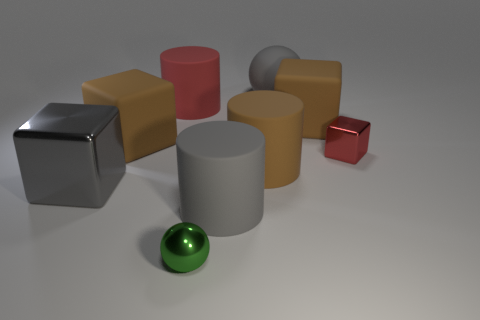Subtract all yellow blocks. Subtract all cyan cylinders. How many blocks are left? 4 Add 1 red cylinders. How many objects exist? 10 Subtract all spheres. How many objects are left? 7 Add 1 big matte balls. How many big matte balls are left? 2 Add 4 big gray shiny cubes. How many big gray shiny cubes exist? 5 Subtract 0 red balls. How many objects are left? 9 Subtract all green cubes. Subtract all big gray things. How many objects are left? 6 